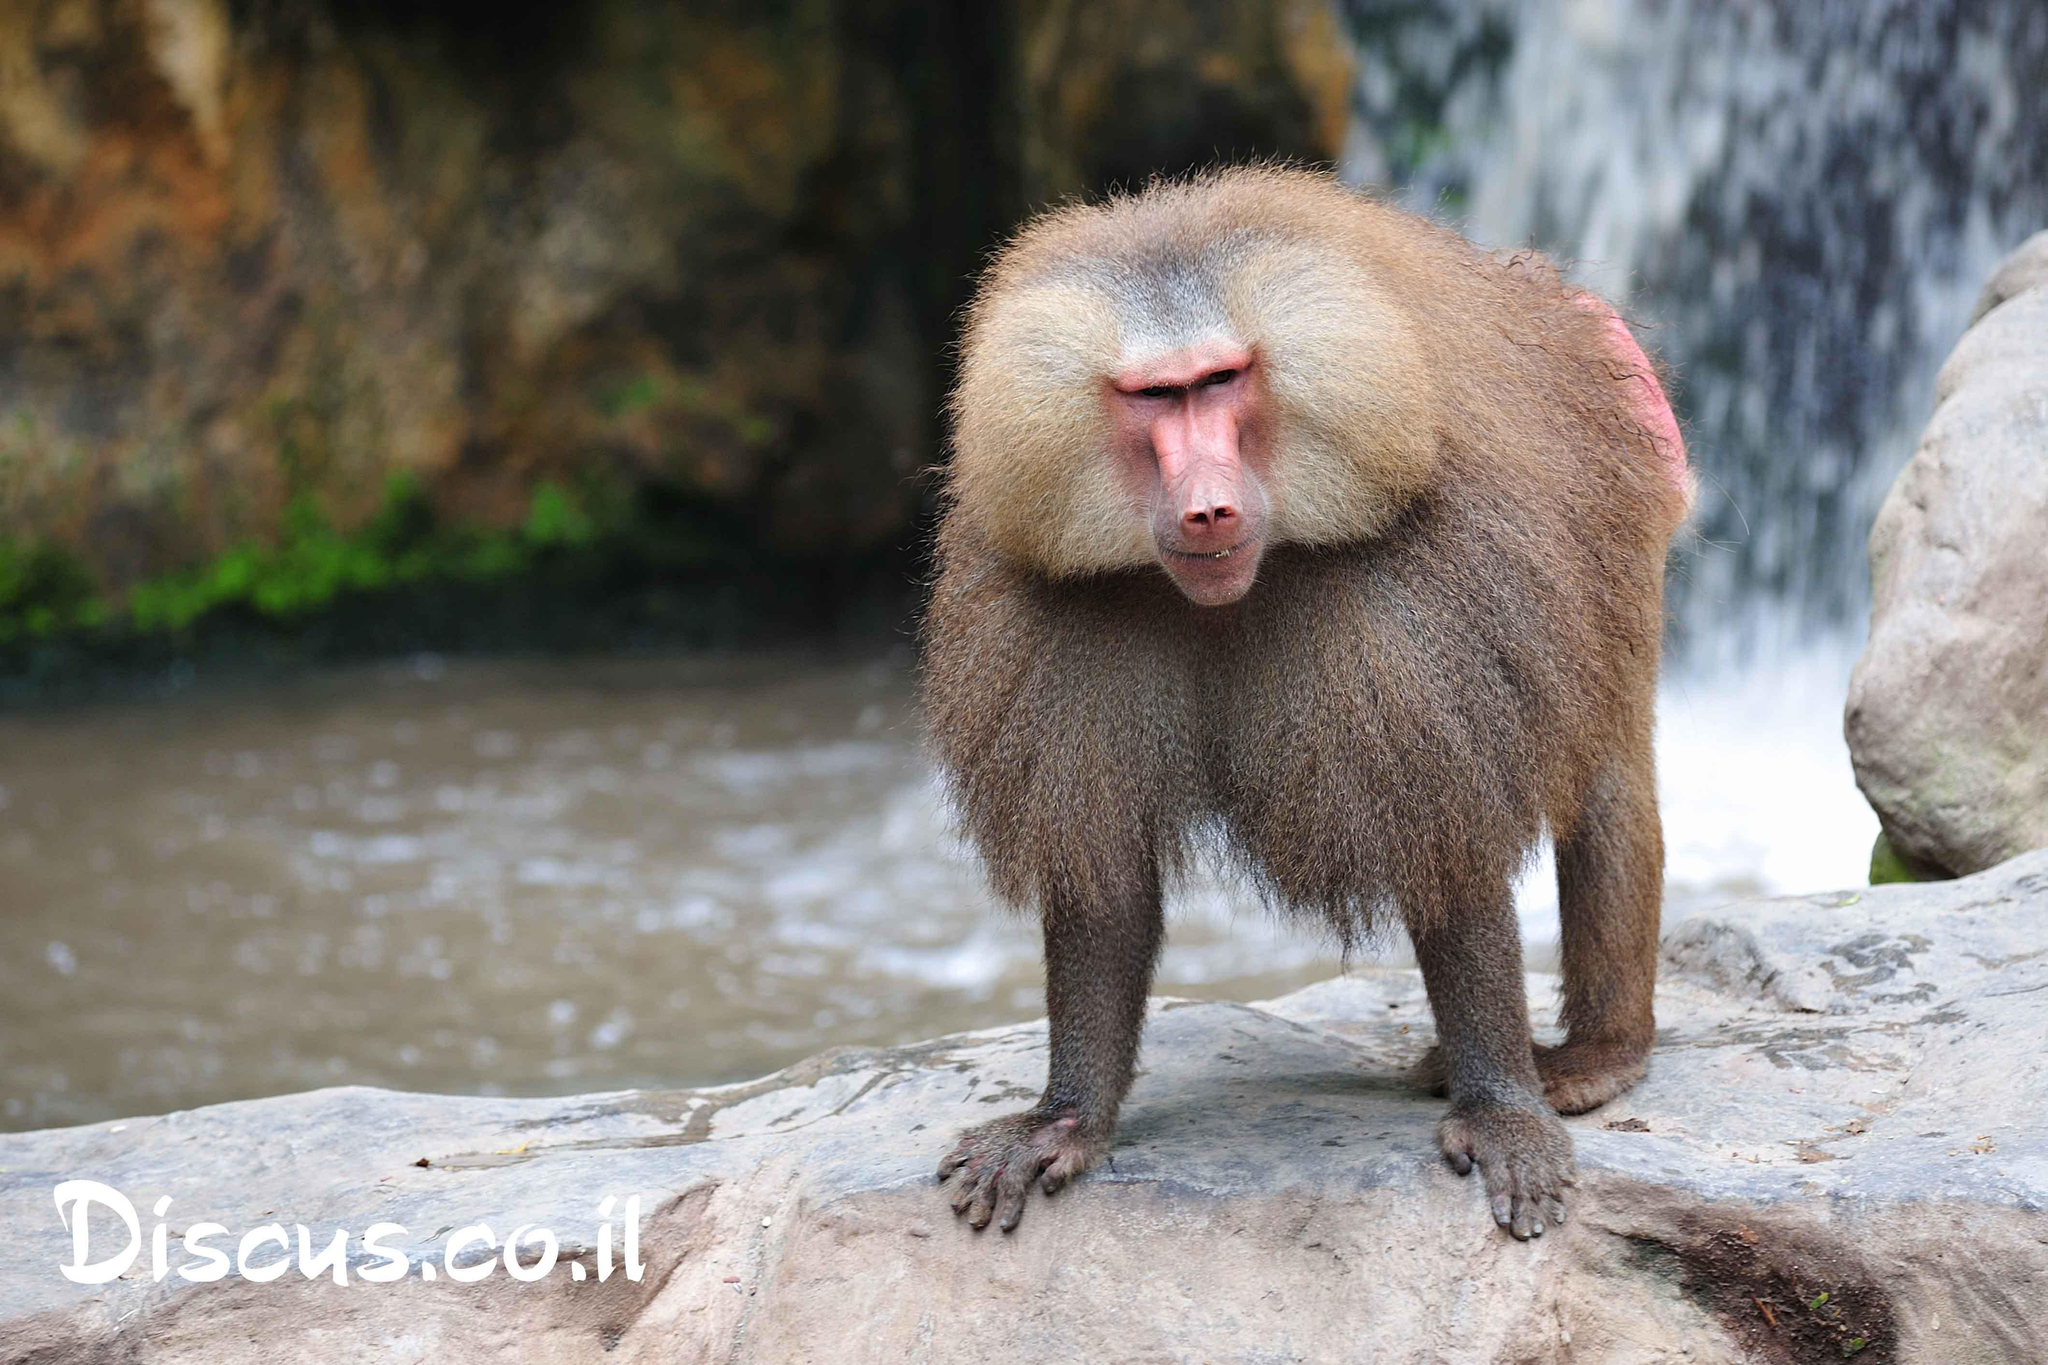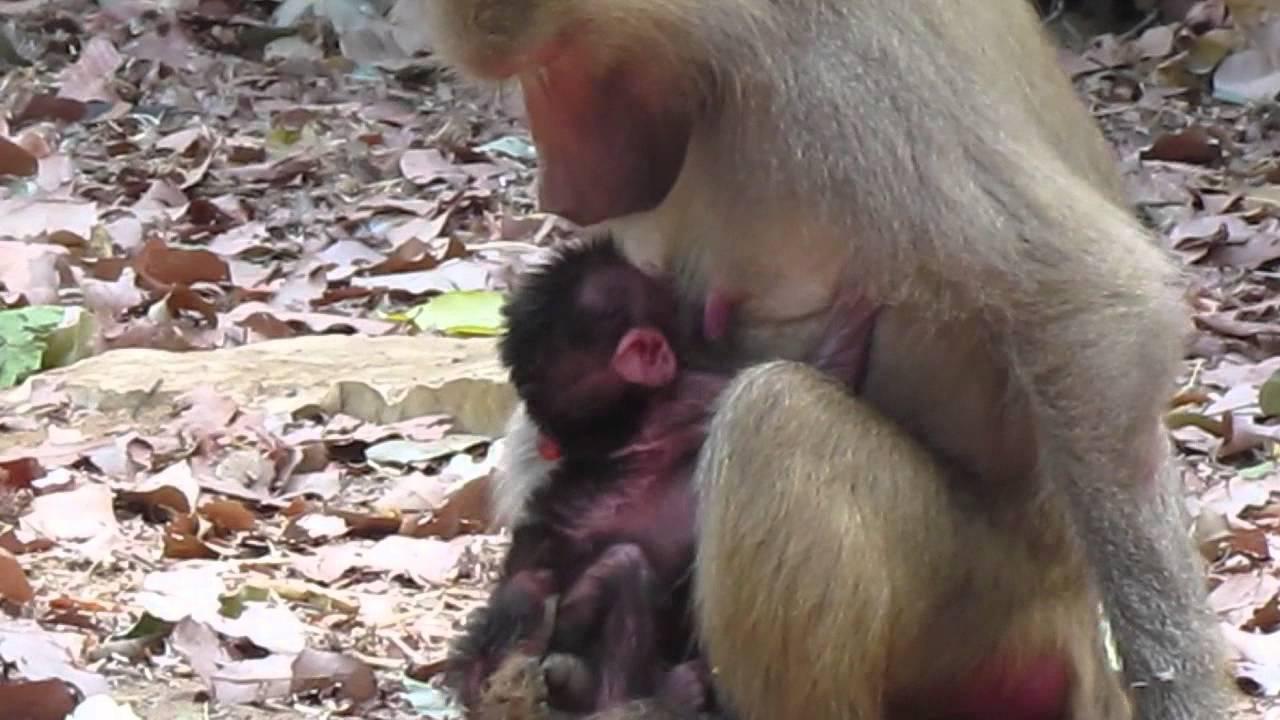The first image is the image on the left, the second image is the image on the right. For the images shown, is this caption "There is a body of water behind a monkey." true? Answer yes or no. Yes. 